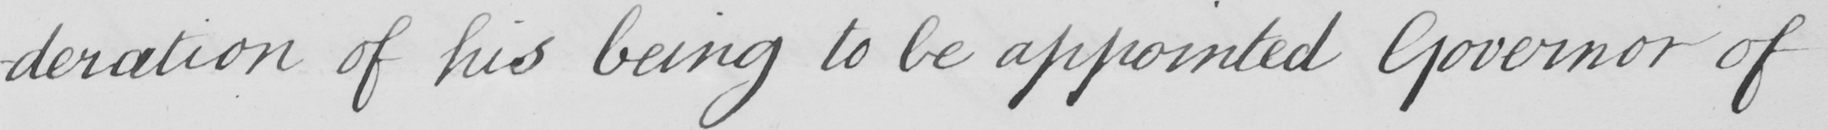Can you read and transcribe this handwriting? -deration of his being to be appointed Governor of 